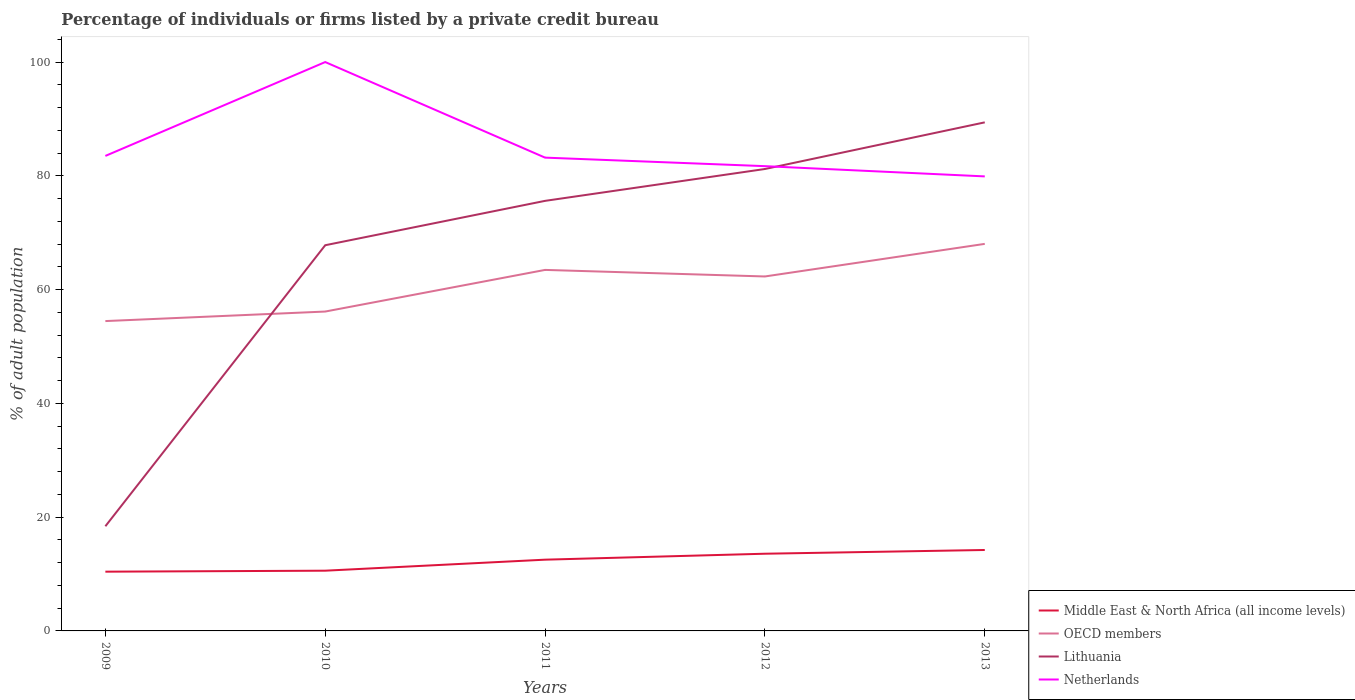Does the line corresponding to Middle East & North Africa (all income levels) intersect with the line corresponding to OECD members?
Your answer should be compact. No. Is the number of lines equal to the number of legend labels?
Ensure brevity in your answer.  Yes. Across all years, what is the maximum percentage of population listed by a private credit bureau in Middle East & North Africa (all income levels)?
Provide a short and direct response. 10.42. What is the total percentage of population listed by a private credit bureau in Lithuania in the graph?
Your response must be concise. -7.8. What is the difference between the highest and the second highest percentage of population listed by a private credit bureau in OECD members?
Provide a succinct answer. 13.57. What is the difference between two consecutive major ticks on the Y-axis?
Your answer should be compact. 20. Are the values on the major ticks of Y-axis written in scientific E-notation?
Ensure brevity in your answer.  No. Where does the legend appear in the graph?
Give a very brief answer. Bottom right. How many legend labels are there?
Provide a short and direct response. 4. How are the legend labels stacked?
Make the answer very short. Vertical. What is the title of the graph?
Offer a terse response. Percentage of individuals or firms listed by a private credit bureau. Does "Northern Mariana Islands" appear as one of the legend labels in the graph?
Provide a succinct answer. No. What is the label or title of the Y-axis?
Your response must be concise. % of adult population. What is the % of adult population in Middle East & North Africa (all income levels) in 2009?
Ensure brevity in your answer.  10.42. What is the % of adult population of OECD members in 2009?
Offer a terse response. 54.47. What is the % of adult population in Lithuania in 2009?
Provide a succinct answer. 18.4. What is the % of adult population in Netherlands in 2009?
Make the answer very short. 83.5. What is the % of adult population in Middle East & North Africa (all income levels) in 2010?
Provide a short and direct response. 10.59. What is the % of adult population in OECD members in 2010?
Offer a very short reply. 56.14. What is the % of adult population of Lithuania in 2010?
Your answer should be compact. 67.8. What is the % of adult population in Middle East & North Africa (all income levels) in 2011?
Make the answer very short. 12.53. What is the % of adult population in OECD members in 2011?
Provide a succinct answer. 63.46. What is the % of adult population of Lithuania in 2011?
Provide a succinct answer. 75.6. What is the % of adult population of Netherlands in 2011?
Offer a terse response. 83.2. What is the % of adult population of Middle East & North Africa (all income levels) in 2012?
Offer a terse response. 13.57. What is the % of adult population in OECD members in 2012?
Offer a very short reply. 62.31. What is the % of adult population in Lithuania in 2012?
Keep it short and to the point. 81.2. What is the % of adult population in Netherlands in 2012?
Your answer should be compact. 81.7. What is the % of adult population in Middle East & North Africa (all income levels) in 2013?
Make the answer very short. 14.23. What is the % of adult population of OECD members in 2013?
Offer a very short reply. 68.04. What is the % of adult population of Lithuania in 2013?
Your answer should be very brief. 89.4. What is the % of adult population in Netherlands in 2013?
Your answer should be very brief. 79.9. Across all years, what is the maximum % of adult population in Middle East & North Africa (all income levels)?
Your answer should be very brief. 14.23. Across all years, what is the maximum % of adult population in OECD members?
Make the answer very short. 68.04. Across all years, what is the maximum % of adult population of Lithuania?
Ensure brevity in your answer.  89.4. Across all years, what is the maximum % of adult population in Netherlands?
Offer a terse response. 100. Across all years, what is the minimum % of adult population in Middle East & North Africa (all income levels)?
Your answer should be very brief. 10.42. Across all years, what is the minimum % of adult population in OECD members?
Your response must be concise. 54.47. Across all years, what is the minimum % of adult population of Lithuania?
Your answer should be compact. 18.4. Across all years, what is the minimum % of adult population of Netherlands?
Give a very brief answer. 79.9. What is the total % of adult population in Middle East & North Africa (all income levels) in the graph?
Ensure brevity in your answer.  61.33. What is the total % of adult population of OECD members in the graph?
Your response must be concise. 304.42. What is the total % of adult population of Lithuania in the graph?
Offer a terse response. 332.4. What is the total % of adult population in Netherlands in the graph?
Offer a terse response. 428.3. What is the difference between the % of adult population of Middle East & North Africa (all income levels) in 2009 and that in 2010?
Your answer should be very brief. -0.17. What is the difference between the % of adult population of OECD members in 2009 and that in 2010?
Offer a very short reply. -1.67. What is the difference between the % of adult population of Lithuania in 2009 and that in 2010?
Ensure brevity in your answer.  -49.4. What is the difference between the % of adult population in Netherlands in 2009 and that in 2010?
Your response must be concise. -16.5. What is the difference between the % of adult population of Middle East & North Africa (all income levels) in 2009 and that in 2011?
Ensure brevity in your answer.  -2.11. What is the difference between the % of adult population in OECD members in 2009 and that in 2011?
Ensure brevity in your answer.  -8.99. What is the difference between the % of adult population of Lithuania in 2009 and that in 2011?
Ensure brevity in your answer.  -57.2. What is the difference between the % of adult population of Middle East & North Africa (all income levels) in 2009 and that in 2012?
Your answer should be compact. -3.16. What is the difference between the % of adult population in OECD members in 2009 and that in 2012?
Offer a terse response. -7.84. What is the difference between the % of adult population of Lithuania in 2009 and that in 2012?
Your answer should be compact. -62.8. What is the difference between the % of adult population in Middle East & North Africa (all income levels) in 2009 and that in 2013?
Provide a succinct answer. -3.81. What is the difference between the % of adult population in OECD members in 2009 and that in 2013?
Your answer should be very brief. -13.57. What is the difference between the % of adult population in Lithuania in 2009 and that in 2013?
Offer a terse response. -71. What is the difference between the % of adult population in Netherlands in 2009 and that in 2013?
Ensure brevity in your answer.  3.6. What is the difference between the % of adult population of Middle East & North Africa (all income levels) in 2010 and that in 2011?
Keep it short and to the point. -1.94. What is the difference between the % of adult population in OECD members in 2010 and that in 2011?
Offer a terse response. -7.32. What is the difference between the % of adult population of Lithuania in 2010 and that in 2011?
Give a very brief answer. -7.8. What is the difference between the % of adult population in Middle East & North Africa (all income levels) in 2010 and that in 2012?
Your answer should be very brief. -2.98. What is the difference between the % of adult population in OECD members in 2010 and that in 2012?
Your answer should be compact. -6.17. What is the difference between the % of adult population in Lithuania in 2010 and that in 2012?
Provide a short and direct response. -13.4. What is the difference between the % of adult population in Middle East & North Africa (all income levels) in 2010 and that in 2013?
Ensure brevity in your answer.  -3.64. What is the difference between the % of adult population in OECD members in 2010 and that in 2013?
Your response must be concise. -11.9. What is the difference between the % of adult population of Lithuania in 2010 and that in 2013?
Give a very brief answer. -21.6. What is the difference between the % of adult population in Netherlands in 2010 and that in 2013?
Your answer should be compact. 20.1. What is the difference between the % of adult population of Middle East & North Africa (all income levels) in 2011 and that in 2012?
Make the answer very short. -1.05. What is the difference between the % of adult population in OECD members in 2011 and that in 2012?
Make the answer very short. 1.15. What is the difference between the % of adult population in Netherlands in 2011 and that in 2012?
Offer a terse response. 1.5. What is the difference between the % of adult population in Middle East & North Africa (all income levels) in 2011 and that in 2013?
Ensure brevity in your answer.  -1.7. What is the difference between the % of adult population in OECD members in 2011 and that in 2013?
Provide a short and direct response. -4.58. What is the difference between the % of adult population in Middle East & North Africa (all income levels) in 2012 and that in 2013?
Give a very brief answer. -0.66. What is the difference between the % of adult population of OECD members in 2012 and that in 2013?
Keep it short and to the point. -5.73. What is the difference between the % of adult population in Lithuania in 2012 and that in 2013?
Provide a short and direct response. -8.2. What is the difference between the % of adult population in Netherlands in 2012 and that in 2013?
Your answer should be compact. 1.8. What is the difference between the % of adult population in Middle East & North Africa (all income levels) in 2009 and the % of adult population in OECD members in 2010?
Provide a succinct answer. -45.73. What is the difference between the % of adult population in Middle East & North Africa (all income levels) in 2009 and the % of adult population in Lithuania in 2010?
Offer a very short reply. -57.38. What is the difference between the % of adult population in Middle East & North Africa (all income levels) in 2009 and the % of adult population in Netherlands in 2010?
Your answer should be very brief. -89.58. What is the difference between the % of adult population of OECD members in 2009 and the % of adult population of Lithuania in 2010?
Your answer should be compact. -13.33. What is the difference between the % of adult population of OECD members in 2009 and the % of adult population of Netherlands in 2010?
Your answer should be very brief. -45.53. What is the difference between the % of adult population of Lithuania in 2009 and the % of adult population of Netherlands in 2010?
Keep it short and to the point. -81.6. What is the difference between the % of adult population in Middle East & North Africa (all income levels) in 2009 and the % of adult population in OECD members in 2011?
Provide a succinct answer. -53.05. What is the difference between the % of adult population in Middle East & North Africa (all income levels) in 2009 and the % of adult population in Lithuania in 2011?
Your answer should be compact. -65.18. What is the difference between the % of adult population of Middle East & North Africa (all income levels) in 2009 and the % of adult population of Netherlands in 2011?
Make the answer very short. -72.78. What is the difference between the % of adult population in OECD members in 2009 and the % of adult population in Lithuania in 2011?
Offer a very short reply. -21.13. What is the difference between the % of adult population in OECD members in 2009 and the % of adult population in Netherlands in 2011?
Give a very brief answer. -28.73. What is the difference between the % of adult population of Lithuania in 2009 and the % of adult population of Netherlands in 2011?
Keep it short and to the point. -64.8. What is the difference between the % of adult population of Middle East & North Africa (all income levels) in 2009 and the % of adult population of OECD members in 2012?
Ensure brevity in your answer.  -51.89. What is the difference between the % of adult population of Middle East & North Africa (all income levels) in 2009 and the % of adult population of Lithuania in 2012?
Offer a terse response. -70.78. What is the difference between the % of adult population of Middle East & North Africa (all income levels) in 2009 and the % of adult population of Netherlands in 2012?
Offer a very short reply. -71.28. What is the difference between the % of adult population of OECD members in 2009 and the % of adult population of Lithuania in 2012?
Provide a succinct answer. -26.73. What is the difference between the % of adult population of OECD members in 2009 and the % of adult population of Netherlands in 2012?
Your response must be concise. -27.23. What is the difference between the % of adult population in Lithuania in 2009 and the % of adult population in Netherlands in 2012?
Offer a very short reply. -63.3. What is the difference between the % of adult population of Middle East & North Africa (all income levels) in 2009 and the % of adult population of OECD members in 2013?
Your answer should be compact. -57.62. What is the difference between the % of adult population of Middle East & North Africa (all income levels) in 2009 and the % of adult population of Lithuania in 2013?
Your answer should be very brief. -78.98. What is the difference between the % of adult population in Middle East & North Africa (all income levels) in 2009 and the % of adult population in Netherlands in 2013?
Offer a terse response. -69.48. What is the difference between the % of adult population in OECD members in 2009 and the % of adult population in Lithuania in 2013?
Your answer should be compact. -34.93. What is the difference between the % of adult population of OECD members in 2009 and the % of adult population of Netherlands in 2013?
Offer a very short reply. -25.43. What is the difference between the % of adult population in Lithuania in 2009 and the % of adult population in Netherlands in 2013?
Your response must be concise. -61.5. What is the difference between the % of adult population of Middle East & North Africa (all income levels) in 2010 and the % of adult population of OECD members in 2011?
Keep it short and to the point. -52.87. What is the difference between the % of adult population of Middle East & North Africa (all income levels) in 2010 and the % of adult population of Lithuania in 2011?
Offer a very short reply. -65.01. What is the difference between the % of adult population of Middle East & North Africa (all income levels) in 2010 and the % of adult population of Netherlands in 2011?
Provide a short and direct response. -72.61. What is the difference between the % of adult population of OECD members in 2010 and the % of adult population of Lithuania in 2011?
Give a very brief answer. -19.46. What is the difference between the % of adult population in OECD members in 2010 and the % of adult population in Netherlands in 2011?
Ensure brevity in your answer.  -27.06. What is the difference between the % of adult population of Lithuania in 2010 and the % of adult population of Netherlands in 2011?
Provide a succinct answer. -15.4. What is the difference between the % of adult population in Middle East & North Africa (all income levels) in 2010 and the % of adult population in OECD members in 2012?
Provide a short and direct response. -51.72. What is the difference between the % of adult population in Middle East & North Africa (all income levels) in 2010 and the % of adult population in Lithuania in 2012?
Provide a succinct answer. -70.61. What is the difference between the % of adult population of Middle East & North Africa (all income levels) in 2010 and the % of adult population of Netherlands in 2012?
Your response must be concise. -71.11. What is the difference between the % of adult population of OECD members in 2010 and the % of adult population of Lithuania in 2012?
Your answer should be compact. -25.06. What is the difference between the % of adult population in OECD members in 2010 and the % of adult population in Netherlands in 2012?
Offer a very short reply. -25.56. What is the difference between the % of adult population in Middle East & North Africa (all income levels) in 2010 and the % of adult population in OECD members in 2013?
Make the answer very short. -57.45. What is the difference between the % of adult population in Middle East & North Africa (all income levels) in 2010 and the % of adult population in Lithuania in 2013?
Keep it short and to the point. -78.81. What is the difference between the % of adult population in Middle East & North Africa (all income levels) in 2010 and the % of adult population in Netherlands in 2013?
Offer a very short reply. -69.31. What is the difference between the % of adult population in OECD members in 2010 and the % of adult population in Lithuania in 2013?
Your answer should be very brief. -33.26. What is the difference between the % of adult population in OECD members in 2010 and the % of adult population in Netherlands in 2013?
Your answer should be very brief. -23.76. What is the difference between the % of adult population in Middle East & North Africa (all income levels) in 2011 and the % of adult population in OECD members in 2012?
Your response must be concise. -49.78. What is the difference between the % of adult population of Middle East & North Africa (all income levels) in 2011 and the % of adult population of Lithuania in 2012?
Offer a very short reply. -68.67. What is the difference between the % of adult population in Middle East & North Africa (all income levels) in 2011 and the % of adult population in Netherlands in 2012?
Provide a short and direct response. -69.17. What is the difference between the % of adult population of OECD members in 2011 and the % of adult population of Lithuania in 2012?
Offer a very short reply. -17.74. What is the difference between the % of adult population of OECD members in 2011 and the % of adult population of Netherlands in 2012?
Provide a succinct answer. -18.24. What is the difference between the % of adult population in Middle East & North Africa (all income levels) in 2011 and the % of adult population in OECD members in 2013?
Offer a very short reply. -55.51. What is the difference between the % of adult population of Middle East & North Africa (all income levels) in 2011 and the % of adult population of Lithuania in 2013?
Provide a succinct answer. -76.88. What is the difference between the % of adult population in Middle East & North Africa (all income levels) in 2011 and the % of adult population in Netherlands in 2013?
Your response must be concise. -67.38. What is the difference between the % of adult population in OECD members in 2011 and the % of adult population in Lithuania in 2013?
Give a very brief answer. -25.94. What is the difference between the % of adult population in OECD members in 2011 and the % of adult population in Netherlands in 2013?
Make the answer very short. -16.44. What is the difference between the % of adult population of Lithuania in 2011 and the % of adult population of Netherlands in 2013?
Your response must be concise. -4.3. What is the difference between the % of adult population of Middle East & North Africa (all income levels) in 2012 and the % of adult population of OECD members in 2013?
Provide a succinct answer. -54.47. What is the difference between the % of adult population in Middle East & North Africa (all income levels) in 2012 and the % of adult population in Lithuania in 2013?
Keep it short and to the point. -75.83. What is the difference between the % of adult population of Middle East & North Africa (all income levels) in 2012 and the % of adult population of Netherlands in 2013?
Your answer should be compact. -66.33. What is the difference between the % of adult population of OECD members in 2012 and the % of adult population of Lithuania in 2013?
Ensure brevity in your answer.  -27.09. What is the difference between the % of adult population in OECD members in 2012 and the % of adult population in Netherlands in 2013?
Your response must be concise. -17.59. What is the average % of adult population in Middle East & North Africa (all income levels) per year?
Your answer should be very brief. 12.27. What is the average % of adult population of OECD members per year?
Ensure brevity in your answer.  60.88. What is the average % of adult population of Lithuania per year?
Your answer should be compact. 66.48. What is the average % of adult population in Netherlands per year?
Your response must be concise. 85.66. In the year 2009, what is the difference between the % of adult population of Middle East & North Africa (all income levels) and % of adult population of OECD members?
Give a very brief answer. -44.05. In the year 2009, what is the difference between the % of adult population in Middle East & North Africa (all income levels) and % of adult population in Lithuania?
Ensure brevity in your answer.  -7.98. In the year 2009, what is the difference between the % of adult population in Middle East & North Africa (all income levels) and % of adult population in Netherlands?
Ensure brevity in your answer.  -73.08. In the year 2009, what is the difference between the % of adult population of OECD members and % of adult population of Lithuania?
Make the answer very short. 36.07. In the year 2009, what is the difference between the % of adult population in OECD members and % of adult population in Netherlands?
Offer a terse response. -29.03. In the year 2009, what is the difference between the % of adult population of Lithuania and % of adult population of Netherlands?
Your response must be concise. -65.1. In the year 2010, what is the difference between the % of adult population in Middle East & North Africa (all income levels) and % of adult population in OECD members?
Ensure brevity in your answer.  -45.55. In the year 2010, what is the difference between the % of adult population of Middle East & North Africa (all income levels) and % of adult population of Lithuania?
Offer a terse response. -57.21. In the year 2010, what is the difference between the % of adult population in Middle East & North Africa (all income levels) and % of adult population in Netherlands?
Provide a succinct answer. -89.41. In the year 2010, what is the difference between the % of adult population of OECD members and % of adult population of Lithuania?
Keep it short and to the point. -11.66. In the year 2010, what is the difference between the % of adult population of OECD members and % of adult population of Netherlands?
Your answer should be very brief. -43.86. In the year 2010, what is the difference between the % of adult population of Lithuania and % of adult population of Netherlands?
Provide a succinct answer. -32.2. In the year 2011, what is the difference between the % of adult population in Middle East & North Africa (all income levels) and % of adult population in OECD members?
Make the answer very short. -50.94. In the year 2011, what is the difference between the % of adult population of Middle East & North Africa (all income levels) and % of adult population of Lithuania?
Provide a succinct answer. -63.08. In the year 2011, what is the difference between the % of adult population of Middle East & North Africa (all income levels) and % of adult population of Netherlands?
Ensure brevity in your answer.  -70.67. In the year 2011, what is the difference between the % of adult population in OECD members and % of adult population in Lithuania?
Provide a short and direct response. -12.14. In the year 2011, what is the difference between the % of adult population of OECD members and % of adult population of Netherlands?
Make the answer very short. -19.74. In the year 2012, what is the difference between the % of adult population in Middle East & North Africa (all income levels) and % of adult population in OECD members?
Keep it short and to the point. -48.74. In the year 2012, what is the difference between the % of adult population in Middle East & North Africa (all income levels) and % of adult population in Lithuania?
Your answer should be compact. -67.63. In the year 2012, what is the difference between the % of adult population of Middle East & North Africa (all income levels) and % of adult population of Netherlands?
Your answer should be very brief. -68.13. In the year 2012, what is the difference between the % of adult population of OECD members and % of adult population of Lithuania?
Ensure brevity in your answer.  -18.89. In the year 2012, what is the difference between the % of adult population of OECD members and % of adult population of Netherlands?
Ensure brevity in your answer.  -19.39. In the year 2012, what is the difference between the % of adult population in Lithuania and % of adult population in Netherlands?
Your response must be concise. -0.5. In the year 2013, what is the difference between the % of adult population of Middle East & North Africa (all income levels) and % of adult population of OECD members?
Make the answer very short. -53.81. In the year 2013, what is the difference between the % of adult population of Middle East & North Africa (all income levels) and % of adult population of Lithuania?
Your answer should be very brief. -75.17. In the year 2013, what is the difference between the % of adult population in Middle East & North Africa (all income levels) and % of adult population in Netherlands?
Ensure brevity in your answer.  -65.67. In the year 2013, what is the difference between the % of adult population of OECD members and % of adult population of Lithuania?
Provide a short and direct response. -21.36. In the year 2013, what is the difference between the % of adult population of OECD members and % of adult population of Netherlands?
Your response must be concise. -11.86. In the year 2013, what is the difference between the % of adult population in Lithuania and % of adult population in Netherlands?
Keep it short and to the point. 9.5. What is the ratio of the % of adult population in Middle East & North Africa (all income levels) in 2009 to that in 2010?
Your response must be concise. 0.98. What is the ratio of the % of adult population in OECD members in 2009 to that in 2010?
Provide a short and direct response. 0.97. What is the ratio of the % of adult population of Lithuania in 2009 to that in 2010?
Keep it short and to the point. 0.27. What is the ratio of the % of adult population in Netherlands in 2009 to that in 2010?
Provide a short and direct response. 0.83. What is the ratio of the % of adult population in Middle East & North Africa (all income levels) in 2009 to that in 2011?
Make the answer very short. 0.83. What is the ratio of the % of adult population of OECD members in 2009 to that in 2011?
Your answer should be compact. 0.86. What is the ratio of the % of adult population in Lithuania in 2009 to that in 2011?
Offer a very short reply. 0.24. What is the ratio of the % of adult population in Middle East & North Africa (all income levels) in 2009 to that in 2012?
Give a very brief answer. 0.77. What is the ratio of the % of adult population in OECD members in 2009 to that in 2012?
Keep it short and to the point. 0.87. What is the ratio of the % of adult population of Lithuania in 2009 to that in 2012?
Offer a very short reply. 0.23. What is the ratio of the % of adult population of Middle East & North Africa (all income levels) in 2009 to that in 2013?
Your response must be concise. 0.73. What is the ratio of the % of adult population of OECD members in 2009 to that in 2013?
Offer a terse response. 0.8. What is the ratio of the % of adult population of Lithuania in 2009 to that in 2013?
Ensure brevity in your answer.  0.21. What is the ratio of the % of adult population of Netherlands in 2009 to that in 2013?
Your answer should be very brief. 1.05. What is the ratio of the % of adult population in Middle East & North Africa (all income levels) in 2010 to that in 2011?
Your answer should be very brief. 0.85. What is the ratio of the % of adult population of OECD members in 2010 to that in 2011?
Provide a succinct answer. 0.88. What is the ratio of the % of adult population in Lithuania in 2010 to that in 2011?
Provide a succinct answer. 0.9. What is the ratio of the % of adult population of Netherlands in 2010 to that in 2011?
Provide a succinct answer. 1.2. What is the ratio of the % of adult population in Middle East & North Africa (all income levels) in 2010 to that in 2012?
Your answer should be very brief. 0.78. What is the ratio of the % of adult population of OECD members in 2010 to that in 2012?
Provide a short and direct response. 0.9. What is the ratio of the % of adult population of Lithuania in 2010 to that in 2012?
Give a very brief answer. 0.83. What is the ratio of the % of adult population in Netherlands in 2010 to that in 2012?
Your response must be concise. 1.22. What is the ratio of the % of adult population of Middle East & North Africa (all income levels) in 2010 to that in 2013?
Provide a succinct answer. 0.74. What is the ratio of the % of adult population in OECD members in 2010 to that in 2013?
Provide a succinct answer. 0.83. What is the ratio of the % of adult population of Lithuania in 2010 to that in 2013?
Offer a very short reply. 0.76. What is the ratio of the % of adult population of Netherlands in 2010 to that in 2013?
Provide a succinct answer. 1.25. What is the ratio of the % of adult population in Middle East & North Africa (all income levels) in 2011 to that in 2012?
Give a very brief answer. 0.92. What is the ratio of the % of adult population in OECD members in 2011 to that in 2012?
Provide a short and direct response. 1.02. What is the ratio of the % of adult population in Lithuania in 2011 to that in 2012?
Your answer should be very brief. 0.93. What is the ratio of the % of adult population in Netherlands in 2011 to that in 2012?
Make the answer very short. 1.02. What is the ratio of the % of adult population in Middle East & North Africa (all income levels) in 2011 to that in 2013?
Offer a terse response. 0.88. What is the ratio of the % of adult population of OECD members in 2011 to that in 2013?
Provide a short and direct response. 0.93. What is the ratio of the % of adult population in Lithuania in 2011 to that in 2013?
Make the answer very short. 0.85. What is the ratio of the % of adult population of Netherlands in 2011 to that in 2013?
Ensure brevity in your answer.  1.04. What is the ratio of the % of adult population of Middle East & North Africa (all income levels) in 2012 to that in 2013?
Offer a very short reply. 0.95. What is the ratio of the % of adult population in OECD members in 2012 to that in 2013?
Make the answer very short. 0.92. What is the ratio of the % of adult population of Lithuania in 2012 to that in 2013?
Ensure brevity in your answer.  0.91. What is the ratio of the % of adult population in Netherlands in 2012 to that in 2013?
Ensure brevity in your answer.  1.02. What is the difference between the highest and the second highest % of adult population in Middle East & North Africa (all income levels)?
Offer a terse response. 0.66. What is the difference between the highest and the second highest % of adult population of OECD members?
Ensure brevity in your answer.  4.58. What is the difference between the highest and the second highest % of adult population in Netherlands?
Give a very brief answer. 16.5. What is the difference between the highest and the lowest % of adult population in Middle East & North Africa (all income levels)?
Your answer should be compact. 3.81. What is the difference between the highest and the lowest % of adult population in OECD members?
Offer a terse response. 13.57. What is the difference between the highest and the lowest % of adult population in Lithuania?
Provide a short and direct response. 71. What is the difference between the highest and the lowest % of adult population of Netherlands?
Offer a terse response. 20.1. 